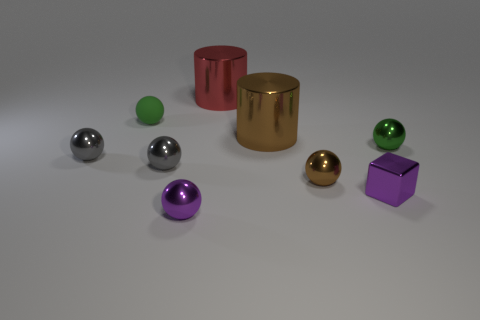Subtract all small brown metallic balls. How many balls are left? 5 Subtract all purple spheres. How many spheres are left? 5 Subtract 3 spheres. How many spheres are left? 3 Subtract all brown balls. Subtract all gray cubes. How many balls are left? 5 Subtract all cylinders. How many objects are left? 7 Add 1 small purple cubes. How many objects exist? 10 Add 2 large objects. How many large objects are left? 4 Add 5 gray balls. How many gray balls exist? 7 Subtract 1 gray balls. How many objects are left? 8 Subtract all small green matte objects. Subtract all big red cylinders. How many objects are left? 7 